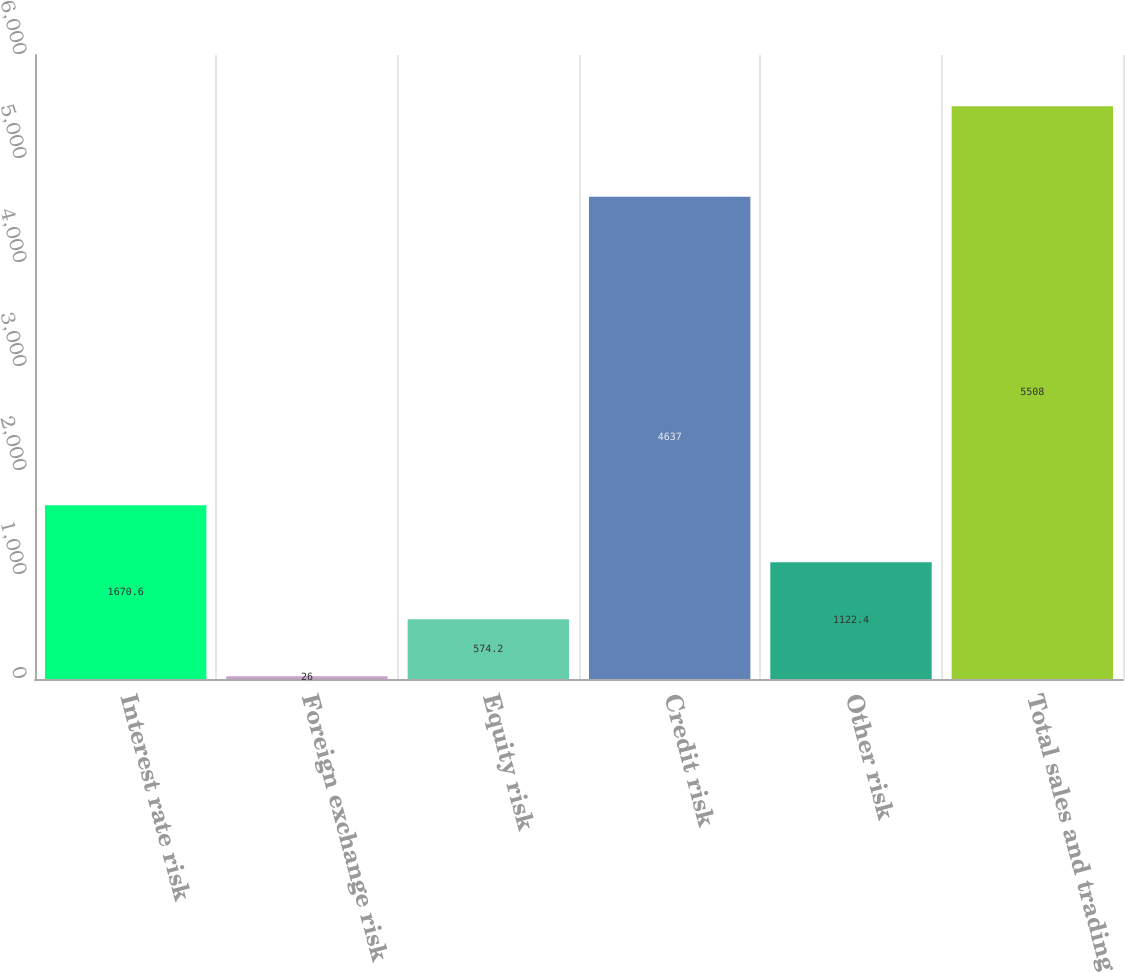<chart> <loc_0><loc_0><loc_500><loc_500><bar_chart><fcel>Interest rate risk<fcel>Foreign exchange risk<fcel>Equity risk<fcel>Credit risk<fcel>Other risk<fcel>Total sales and trading<nl><fcel>1670.6<fcel>26<fcel>574.2<fcel>4637<fcel>1122.4<fcel>5508<nl></chart> 